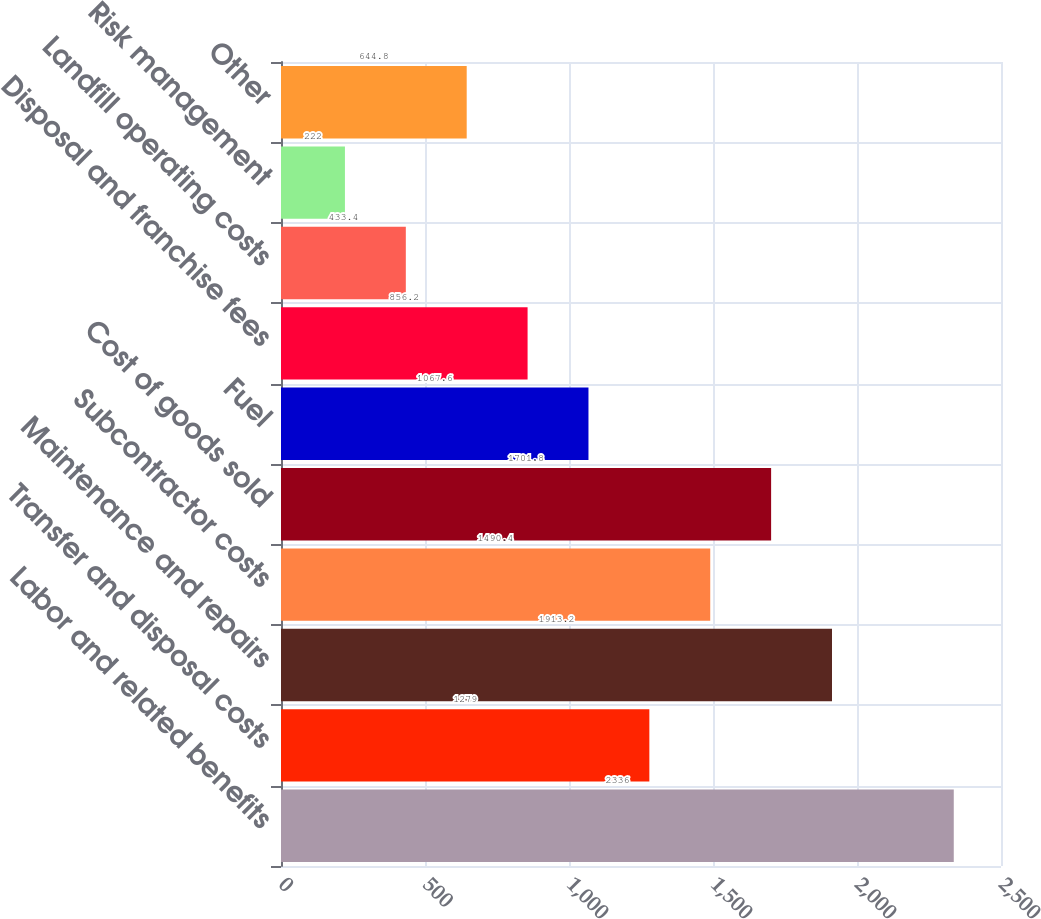<chart> <loc_0><loc_0><loc_500><loc_500><bar_chart><fcel>Labor and related benefits<fcel>Transfer and disposal costs<fcel>Maintenance and repairs<fcel>Subcontractor costs<fcel>Cost of goods sold<fcel>Fuel<fcel>Disposal and franchise fees<fcel>Landfill operating costs<fcel>Risk management<fcel>Other<nl><fcel>2336<fcel>1279<fcel>1913.2<fcel>1490.4<fcel>1701.8<fcel>1067.6<fcel>856.2<fcel>433.4<fcel>222<fcel>644.8<nl></chart> 